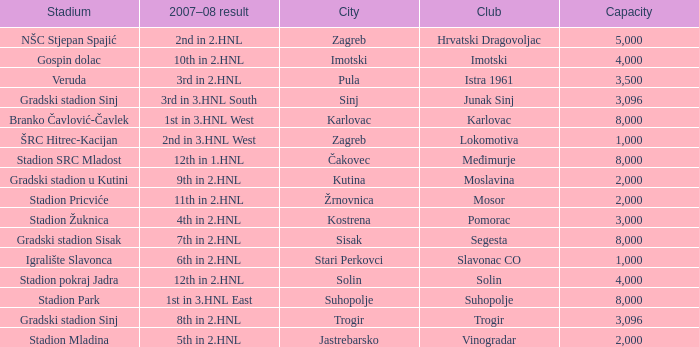What stadium has 9th in 2.hnl as the 2007-08 result? Gradski stadion u Kutini. 